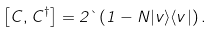Convert formula to latex. <formula><loc_0><loc_0><loc_500><loc_500>\left [ C , C ^ { \dag } \right ] = 2 \theta \left ( 1 - N | v \rangle \langle v | \right ) .</formula> 